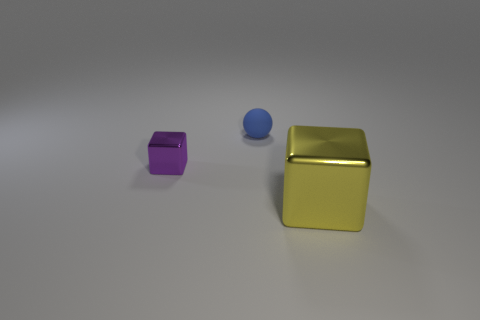Is there any other thing that is the same material as the blue object?
Your answer should be very brief. No. Is there any other thing that is the same size as the yellow object?
Offer a very short reply. No. Are there the same number of yellow metal objects that are behind the yellow cube and blue objects?
Make the answer very short. No. Are there any other big shiny blocks that have the same color as the big shiny block?
Ensure brevity in your answer.  No. Is the size of the purple shiny thing the same as the blue ball?
Your answer should be very brief. Yes. What is the size of the metal object that is on the left side of the shiny object that is on the right side of the blue rubber ball?
Your response must be concise. Small. There is a object that is behind the yellow cube and in front of the small rubber thing; what is its size?
Your answer should be very brief. Small. How many other objects have the same size as the rubber thing?
Your answer should be very brief. 1. How many metal objects are yellow blocks or small blue cylinders?
Your answer should be very brief. 1. There is a cube on the right side of the shiny object to the left of the yellow block; what is it made of?
Provide a succinct answer. Metal. 